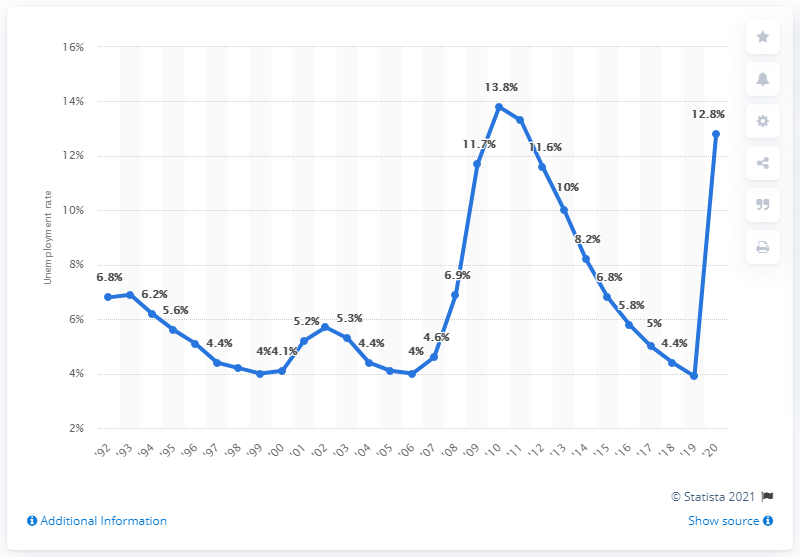List a handful of essential elements in this visual. In 2020, the unemployment rate in Nevada was 12.8%. In 2010, Nevada's unemployment rate was 3.9 percent. 